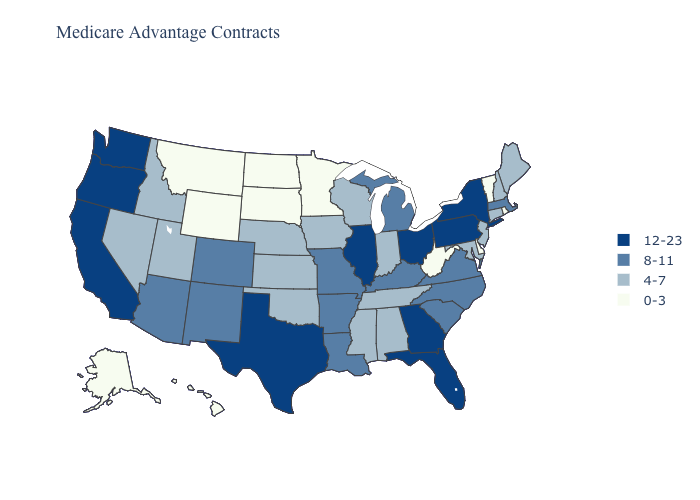What is the lowest value in states that border Utah?
Keep it brief. 0-3. What is the lowest value in the USA?
Be succinct. 0-3. What is the highest value in the USA?
Keep it brief. 12-23. What is the lowest value in the South?
Quick response, please. 0-3. What is the highest value in the USA?
Quick response, please. 12-23. Which states have the highest value in the USA?
Concise answer only. California, Florida, Georgia, Illinois, New York, Ohio, Oregon, Pennsylvania, Texas, Washington. Name the states that have a value in the range 12-23?
Short answer required. California, Florida, Georgia, Illinois, New York, Ohio, Oregon, Pennsylvania, Texas, Washington. Does Idaho have the highest value in the USA?
Give a very brief answer. No. Name the states that have a value in the range 12-23?
Give a very brief answer. California, Florida, Georgia, Illinois, New York, Ohio, Oregon, Pennsylvania, Texas, Washington. Does the first symbol in the legend represent the smallest category?
Answer briefly. No. Does Minnesota have the lowest value in the MidWest?
Give a very brief answer. Yes. Does Minnesota have the same value as Georgia?
Give a very brief answer. No. What is the value of Maryland?
Write a very short answer. 4-7. What is the highest value in the USA?
Concise answer only. 12-23. Which states have the lowest value in the USA?
Write a very short answer. Alaska, Delaware, Hawaii, Minnesota, Montana, North Dakota, Rhode Island, South Dakota, Vermont, West Virginia, Wyoming. 